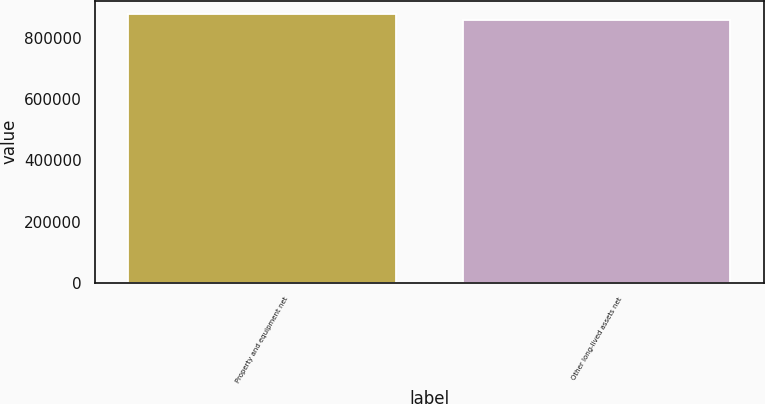Convert chart. <chart><loc_0><loc_0><loc_500><loc_500><bar_chart><fcel>Property and equipment net<fcel>Other long-lived assets net<nl><fcel>879069<fcel>858255<nl></chart> 